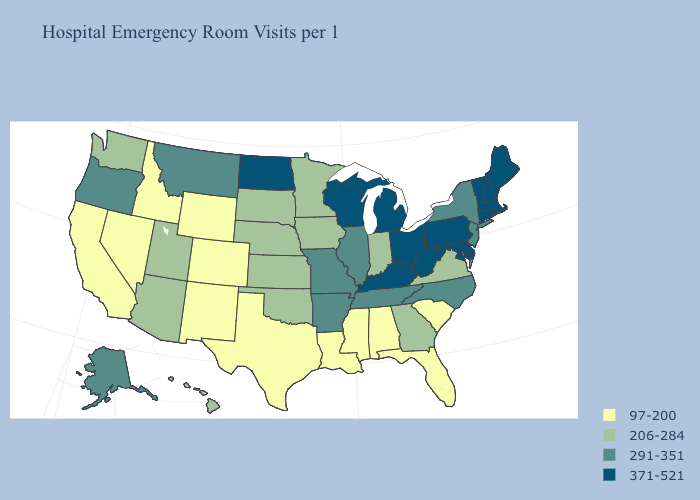Name the states that have a value in the range 206-284?
Give a very brief answer. Arizona, Georgia, Hawaii, Indiana, Iowa, Kansas, Minnesota, Nebraska, Oklahoma, South Dakota, Utah, Virginia, Washington. Among the states that border Arizona , which have the lowest value?
Quick response, please. California, Colorado, Nevada, New Mexico. Does New Jersey have the highest value in the Northeast?
Short answer required. No. Among the states that border Minnesota , does North Dakota have the highest value?
Keep it brief. Yes. How many symbols are there in the legend?
Quick response, please. 4. What is the value of Wisconsin?
Be succinct. 371-521. Name the states that have a value in the range 206-284?
Short answer required. Arizona, Georgia, Hawaii, Indiana, Iowa, Kansas, Minnesota, Nebraska, Oklahoma, South Dakota, Utah, Virginia, Washington. What is the value of Kansas?
Answer briefly. 206-284. Does Montana have the highest value in the West?
Answer briefly. Yes. Does New Mexico have a lower value than Nebraska?
Keep it brief. Yes. Name the states that have a value in the range 291-351?
Write a very short answer. Alaska, Arkansas, Illinois, Missouri, Montana, New Jersey, New York, North Carolina, Oregon, Tennessee. Does Arkansas have the lowest value in the USA?
Be succinct. No. Does Louisiana have the lowest value in the South?
Answer briefly. Yes. What is the value of Vermont?
Give a very brief answer. 371-521. Which states have the highest value in the USA?
Quick response, please. Connecticut, Delaware, Kentucky, Maine, Maryland, Massachusetts, Michigan, New Hampshire, North Dakota, Ohio, Pennsylvania, Rhode Island, Vermont, West Virginia, Wisconsin. 